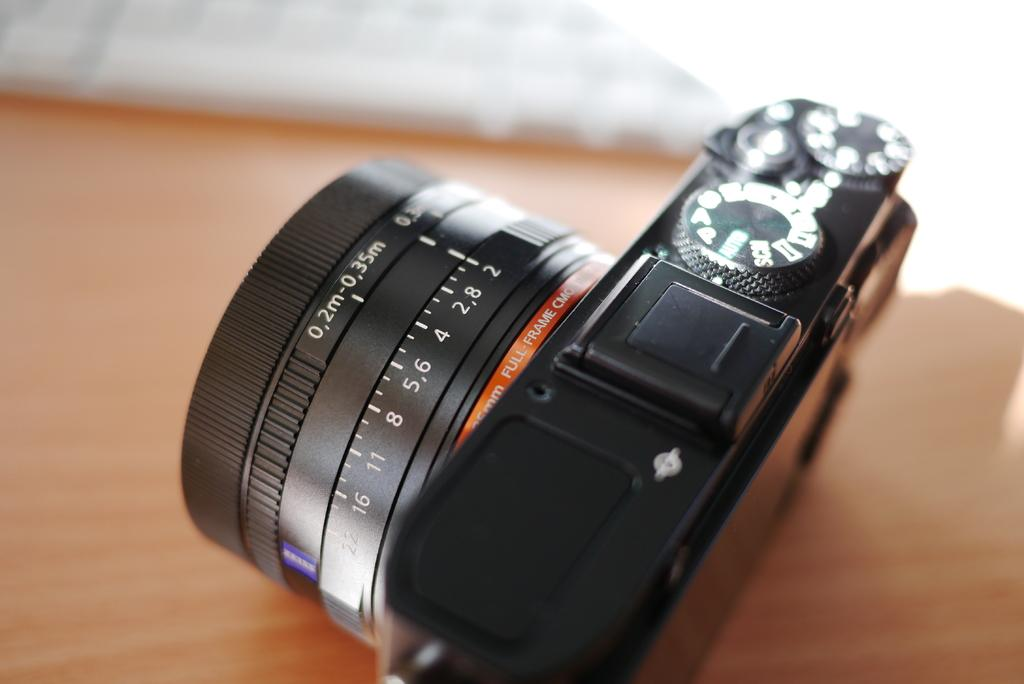<image>
Present a compact description of the photo's key features. A professional black camera with a green Auto button on the top. 